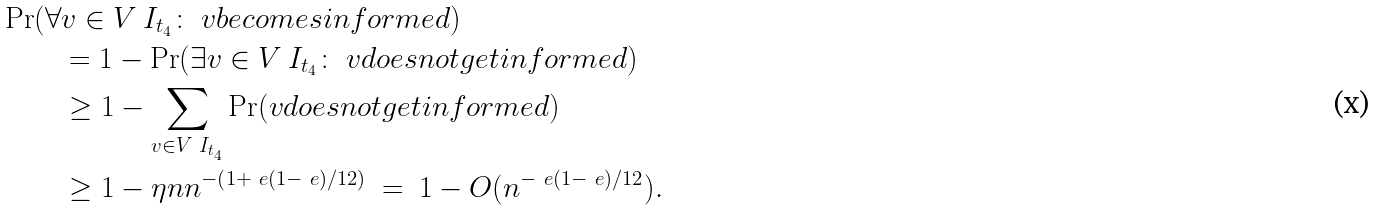<formula> <loc_0><loc_0><loc_500><loc_500>\Pr ( \forall & v \in V \ I _ { t _ { 4 } } \colon \ v b e c o m e s i n f o r m e d ) \\ & = 1 - \Pr ( \exists v \in V \ I _ { t _ { 4 } } \colon \ v d o e s n o t g e t i n f o r m e d ) \\ & \geq 1 - \sum _ { v \in V \ I _ { t _ { 4 } } } \Pr ( v d o e s n o t g e t i n f o r m e d ) \\ & \geq 1 - \eta n n ^ { - \left ( 1 + \ e ( 1 - \ e ) / 1 2 \right ) } \ = \ 1 - O ( n ^ { - \ e ( 1 - \ e ) / 1 2 } ) .</formula> 